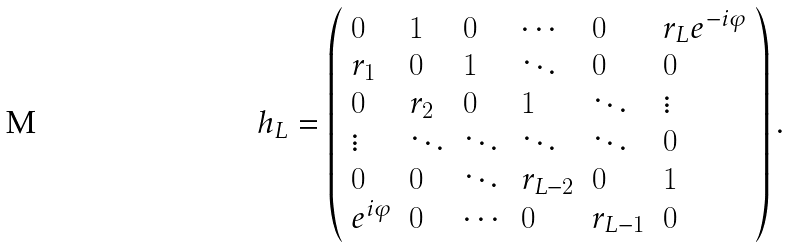Convert formula to latex. <formula><loc_0><loc_0><loc_500><loc_500>h _ { L } = \left ( \begin{array} { l l l l l l } 0 & 1 & 0 & \cdots & 0 & r _ { L } e ^ { - i \varphi } \\ r _ { 1 } & 0 & 1 & \ddots & 0 & 0 \\ 0 & r _ { 2 } & 0 & 1 & \ddots & \vdots \\ \vdots & \ddots & \ddots & \ddots & \ddots & 0 \\ 0 & 0 & \ddots & r _ { L - 2 } & 0 & 1 \\ e ^ { i \varphi } & 0 & \cdots & 0 & r _ { L - 1 } & 0 \end{array} \right ) .</formula> 